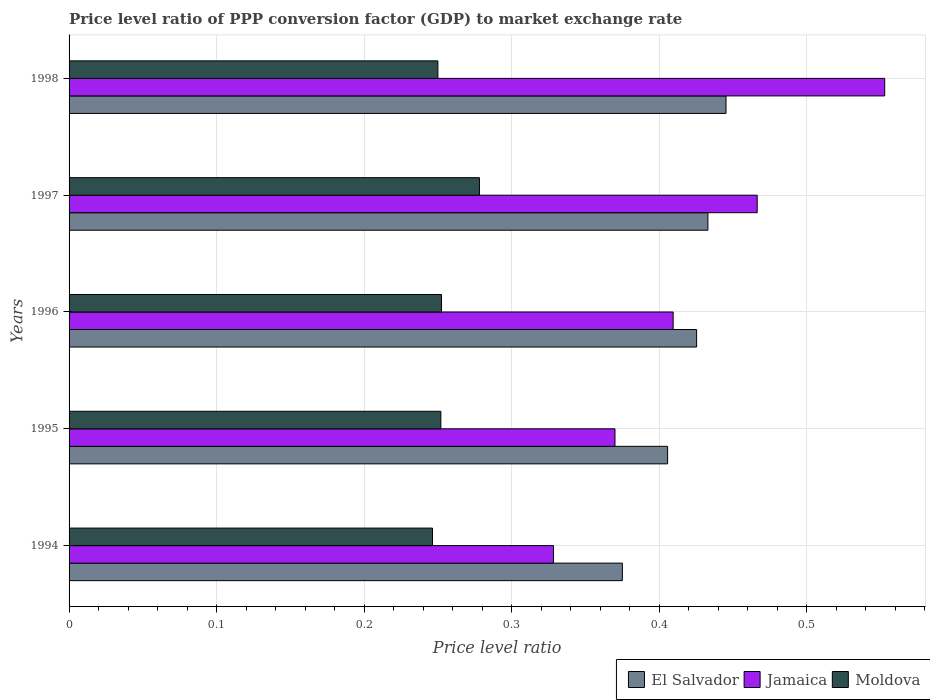How many different coloured bars are there?
Your response must be concise. 3. Are the number of bars per tick equal to the number of legend labels?
Offer a terse response. Yes. Are the number of bars on each tick of the Y-axis equal?
Keep it short and to the point. Yes. How many bars are there on the 3rd tick from the top?
Give a very brief answer. 3. How many bars are there on the 4th tick from the bottom?
Provide a succinct answer. 3. What is the price level ratio in Jamaica in 1994?
Your answer should be compact. 0.33. Across all years, what is the maximum price level ratio in El Salvador?
Make the answer very short. 0.45. Across all years, what is the minimum price level ratio in Jamaica?
Give a very brief answer. 0.33. In which year was the price level ratio in El Salvador maximum?
Give a very brief answer. 1998. What is the total price level ratio in El Salvador in the graph?
Provide a short and direct response. 2.08. What is the difference between the price level ratio in Moldova in 1994 and that in 1997?
Your answer should be very brief. -0.03. What is the difference between the price level ratio in Moldova in 1998 and the price level ratio in El Salvador in 1995?
Your answer should be very brief. -0.16. What is the average price level ratio in El Salvador per year?
Make the answer very short. 0.42. In the year 1995, what is the difference between the price level ratio in Moldova and price level ratio in Jamaica?
Offer a terse response. -0.12. In how many years, is the price level ratio in Jamaica greater than 0.06 ?
Ensure brevity in your answer.  5. What is the ratio of the price level ratio in El Salvador in 1994 to that in 1998?
Offer a very short reply. 0.84. Is the price level ratio in Moldova in 1994 less than that in 1998?
Provide a short and direct response. Yes. What is the difference between the highest and the second highest price level ratio in Moldova?
Your answer should be very brief. 0.03. What is the difference between the highest and the lowest price level ratio in Moldova?
Keep it short and to the point. 0.03. In how many years, is the price level ratio in El Salvador greater than the average price level ratio in El Salvador taken over all years?
Make the answer very short. 3. What does the 2nd bar from the top in 1995 represents?
Give a very brief answer. Jamaica. What does the 2nd bar from the bottom in 1998 represents?
Ensure brevity in your answer.  Jamaica. Is it the case that in every year, the sum of the price level ratio in El Salvador and price level ratio in Jamaica is greater than the price level ratio in Moldova?
Give a very brief answer. Yes. How many bars are there?
Provide a short and direct response. 15. Are the values on the major ticks of X-axis written in scientific E-notation?
Your answer should be very brief. No. What is the title of the graph?
Your answer should be compact. Price level ratio of PPP conversion factor (GDP) to market exchange rate. Does "Vanuatu" appear as one of the legend labels in the graph?
Give a very brief answer. No. What is the label or title of the X-axis?
Offer a very short reply. Price level ratio. What is the label or title of the Y-axis?
Your answer should be very brief. Years. What is the Price level ratio of El Salvador in 1994?
Keep it short and to the point. 0.37. What is the Price level ratio of Jamaica in 1994?
Give a very brief answer. 0.33. What is the Price level ratio in Moldova in 1994?
Your response must be concise. 0.25. What is the Price level ratio of El Salvador in 1995?
Offer a very short reply. 0.41. What is the Price level ratio in Jamaica in 1995?
Your response must be concise. 0.37. What is the Price level ratio in Moldova in 1995?
Keep it short and to the point. 0.25. What is the Price level ratio of El Salvador in 1996?
Provide a short and direct response. 0.43. What is the Price level ratio in Jamaica in 1996?
Your response must be concise. 0.41. What is the Price level ratio in Moldova in 1996?
Keep it short and to the point. 0.25. What is the Price level ratio of El Salvador in 1997?
Give a very brief answer. 0.43. What is the Price level ratio of Jamaica in 1997?
Provide a succinct answer. 0.47. What is the Price level ratio of Moldova in 1997?
Give a very brief answer. 0.28. What is the Price level ratio in El Salvador in 1998?
Offer a very short reply. 0.45. What is the Price level ratio of Jamaica in 1998?
Offer a terse response. 0.55. What is the Price level ratio in Moldova in 1998?
Offer a very short reply. 0.25. Across all years, what is the maximum Price level ratio in El Salvador?
Offer a very short reply. 0.45. Across all years, what is the maximum Price level ratio of Jamaica?
Your answer should be compact. 0.55. Across all years, what is the maximum Price level ratio of Moldova?
Provide a short and direct response. 0.28. Across all years, what is the minimum Price level ratio of El Salvador?
Your answer should be compact. 0.37. Across all years, what is the minimum Price level ratio of Jamaica?
Your answer should be very brief. 0.33. Across all years, what is the minimum Price level ratio of Moldova?
Provide a short and direct response. 0.25. What is the total Price level ratio of El Salvador in the graph?
Your response must be concise. 2.08. What is the total Price level ratio in Jamaica in the graph?
Your answer should be compact. 2.13. What is the total Price level ratio of Moldova in the graph?
Give a very brief answer. 1.28. What is the difference between the Price level ratio in El Salvador in 1994 and that in 1995?
Provide a succinct answer. -0.03. What is the difference between the Price level ratio in Jamaica in 1994 and that in 1995?
Your answer should be compact. -0.04. What is the difference between the Price level ratio of Moldova in 1994 and that in 1995?
Keep it short and to the point. -0.01. What is the difference between the Price level ratio in El Salvador in 1994 and that in 1996?
Your response must be concise. -0.05. What is the difference between the Price level ratio of Jamaica in 1994 and that in 1996?
Offer a very short reply. -0.08. What is the difference between the Price level ratio of Moldova in 1994 and that in 1996?
Ensure brevity in your answer.  -0.01. What is the difference between the Price level ratio of El Salvador in 1994 and that in 1997?
Your answer should be very brief. -0.06. What is the difference between the Price level ratio in Jamaica in 1994 and that in 1997?
Provide a succinct answer. -0.14. What is the difference between the Price level ratio of Moldova in 1994 and that in 1997?
Offer a terse response. -0.03. What is the difference between the Price level ratio of El Salvador in 1994 and that in 1998?
Give a very brief answer. -0.07. What is the difference between the Price level ratio of Jamaica in 1994 and that in 1998?
Your response must be concise. -0.22. What is the difference between the Price level ratio of Moldova in 1994 and that in 1998?
Ensure brevity in your answer.  -0. What is the difference between the Price level ratio in El Salvador in 1995 and that in 1996?
Your answer should be compact. -0.02. What is the difference between the Price level ratio of Jamaica in 1995 and that in 1996?
Provide a short and direct response. -0.04. What is the difference between the Price level ratio of Moldova in 1995 and that in 1996?
Provide a short and direct response. -0. What is the difference between the Price level ratio of El Salvador in 1995 and that in 1997?
Give a very brief answer. -0.03. What is the difference between the Price level ratio in Jamaica in 1995 and that in 1997?
Keep it short and to the point. -0.1. What is the difference between the Price level ratio of Moldova in 1995 and that in 1997?
Provide a short and direct response. -0.03. What is the difference between the Price level ratio of El Salvador in 1995 and that in 1998?
Keep it short and to the point. -0.04. What is the difference between the Price level ratio in Jamaica in 1995 and that in 1998?
Ensure brevity in your answer.  -0.18. What is the difference between the Price level ratio in Moldova in 1995 and that in 1998?
Provide a succinct answer. 0. What is the difference between the Price level ratio in El Salvador in 1996 and that in 1997?
Provide a short and direct response. -0.01. What is the difference between the Price level ratio of Jamaica in 1996 and that in 1997?
Your answer should be compact. -0.06. What is the difference between the Price level ratio in Moldova in 1996 and that in 1997?
Offer a terse response. -0.03. What is the difference between the Price level ratio of El Salvador in 1996 and that in 1998?
Offer a very short reply. -0.02. What is the difference between the Price level ratio of Jamaica in 1996 and that in 1998?
Provide a short and direct response. -0.14. What is the difference between the Price level ratio of Moldova in 1996 and that in 1998?
Your answer should be very brief. 0. What is the difference between the Price level ratio of El Salvador in 1997 and that in 1998?
Offer a very short reply. -0.01. What is the difference between the Price level ratio of Jamaica in 1997 and that in 1998?
Provide a succinct answer. -0.09. What is the difference between the Price level ratio in Moldova in 1997 and that in 1998?
Offer a very short reply. 0.03. What is the difference between the Price level ratio of El Salvador in 1994 and the Price level ratio of Jamaica in 1995?
Give a very brief answer. 0.01. What is the difference between the Price level ratio of El Salvador in 1994 and the Price level ratio of Moldova in 1995?
Your answer should be very brief. 0.12. What is the difference between the Price level ratio of Jamaica in 1994 and the Price level ratio of Moldova in 1995?
Offer a terse response. 0.08. What is the difference between the Price level ratio of El Salvador in 1994 and the Price level ratio of Jamaica in 1996?
Your response must be concise. -0.03. What is the difference between the Price level ratio of El Salvador in 1994 and the Price level ratio of Moldova in 1996?
Your answer should be very brief. 0.12. What is the difference between the Price level ratio in Jamaica in 1994 and the Price level ratio in Moldova in 1996?
Offer a terse response. 0.08. What is the difference between the Price level ratio of El Salvador in 1994 and the Price level ratio of Jamaica in 1997?
Provide a succinct answer. -0.09. What is the difference between the Price level ratio in El Salvador in 1994 and the Price level ratio in Moldova in 1997?
Ensure brevity in your answer.  0.1. What is the difference between the Price level ratio of Jamaica in 1994 and the Price level ratio of Moldova in 1997?
Make the answer very short. 0.05. What is the difference between the Price level ratio in El Salvador in 1994 and the Price level ratio in Jamaica in 1998?
Provide a succinct answer. -0.18. What is the difference between the Price level ratio in El Salvador in 1994 and the Price level ratio in Moldova in 1998?
Provide a short and direct response. 0.12. What is the difference between the Price level ratio in Jamaica in 1994 and the Price level ratio in Moldova in 1998?
Ensure brevity in your answer.  0.08. What is the difference between the Price level ratio in El Salvador in 1995 and the Price level ratio in Jamaica in 1996?
Ensure brevity in your answer.  -0. What is the difference between the Price level ratio of El Salvador in 1995 and the Price level ratio of Moldova in 1996?
Provide a short and direct response. 0.15. What is the difference between the Price level ratio of Jamaica in 1995 and the Price level ratio of Moldova in 1996?
Ensure brevity in your answer.  0.12. What is the difference between the Price level ratio in El Salvador in 1995 and the Price level ratio in Jamaica in 1997?
Provide a succinct answer. -0.06. What is the difference between the Price level ratio of El Salvador in 1995 and the Price level ratio of Moldova in 1997?
Your answer should be very brief. 0.13. What is the difference between the Price level ratio in Jamaica in 1995 and the Price level ratio in Moldova in 1997?
Keep it short and to the point. 0.09. What is the difference between the Price level ratio of El Salvador in 1995 and the Price level ratio of Jamaica in 1998?
Your answer should be compact. -0.15. What is the difference between the Price level ratio of El Salvador in 1995 and the Price level ratio of Moldova in 1998?
Ensure brevity in your answer.  0.16. What is the difference between the Price level ratio of Jamaica in 1995 and the Price level ratio of Moldova in 1998?
Offer a terse response. 0.12. What is the difference between the Price level ratio in El Salvador in 1996 and the Price level ratio in Jamaica in 1997?
Offer a terse response. -0.04. What is the difference between the Price level ratio of El Salvador in 1996 and the Price level ratio of Moldova in 1997?
Provide a short and direct response. 0.15. What is the difference between the Price level ratio of Jamaica in 1996 and the Price level ratio of Moldova in 1997?
Your response must be concise. 0.13. What is the difference between the Price level ratio of El Salvador in 1996 and the Price level ratio of Jamaica in 1998?
Keep it short and to the point. -0.13. What is the difference between the Price level ratio in El Salvador in 1996 and the Price level ratio in Moldova in 1998?
Offer a very short reply. 0.18. What is the difference between the Price level ratio of Jamaica in 1996 and the Price level ratio of Moldova in 1998?
Keep it short and to the point. 0.16. What is the difference between the Price level ratio in El Salvador in 1997 and the Price level ratio in Jamaica in 1998?
Your response must be concise. -0.12. What is the difference between the Price level ratio of El Salvador in 1997 and the Price level ratio of Moldova in 1998?
Make the answer very short. 0.18. What is the difference between the Price level ratio in Jamaica in 1997 and the Price level ratio in Moldova in 1998?
Your response must be concise. 0.22. What is the average Price level ratio of El Salvador per year?
Provide a short and direct response. 0.42. What is the average Price level ratio in Jamaica per year?
Provide a succinct answer. 0.43. What is the average Price level ratio of Moldova per year?
Ensure brevity in your answer.  0.26. In the year 1994, what is the difference between the Price level ratio of El Salvador and Price level ratio of Jamaica?
Offer a very short reply. 0.05. In the year 1994, what is the difference between the Price level ratio of El Salvador and Price level ratio of Moldova?
Make the answer very short. 0.13. In the year 1994, what is the difference between the Price level ratio in Jamaica and Price level ratio in Moldova?
Make the answer very short. 0.08. In the year 1995, what is the difference between the Price level ratio in El Salvador and Price level ratio in Jamaica?
Provide a short and direct response. 0.04. In the year 1995, what is the difference between the Price level ratio of El Salvador and Price level ratio of Moldova?
Your response must be concise. 0.15. In the year 1995, what is the difference between the Price level ratio of Jamaica and Price level ratio of Moldova?
Provide a short and direct response. 0.12. In the year 1996, what is the difference between the Price level ratio of El Salvador and Price level ratio of Jamaica?
Provide a succinct answer. 0.02. In the year 1996, what is the difference between the Price level ratio in El Salvador and Price level ratio in Moldova?
Provide a short and direct response. 0.17. In the year 1996, what is the difference between the Price level ratio of Jamaica and Price level ratio of Moldova?
Make the answer very short. 0.16. In the year 1997, what is the difference between the Price level ratio of El Salvador and Price level ratio of Jamaica?
Offer a terse response. -0.03. In the year 1997, what is the difference between the Price level ratio of El Salvador and Price level ratio of Moldova?
Your answer should be very brief. 0.15. In the year 1997, what is the difference between the Price level ratio in Jamaica and Price level ratio in Moldova?
Your response must be concise. 0.19. In the year 1998, what is the difference between the Price level ratio in El Salvador and Price level ratio in Jamaica?
Give a very brief answer. -0.11. In the year 1998, what is the difference between the Price level ratio of El Salvador and Price level ratio of Moldova?
Your response must be concise. 0.2. In the year 1998, what is the difference between the Price level ratio of Jamaica and Price level ratio of Moldova?
Make the answer very short. 0.3. What is the ratio of the Price level ratio of El Salvador in 1994 to that in 1995?
Keep it short and to the point. 0.92. What is the ratio of the Price level ratio of Jamaica in 1994 to that in 1995?
Your answer should be very brief. 0.89. What is the ratio of the Price level ratio in Moldova in 1994 to that in 1995?
Make the answer very short. 0.98. What is the ratio of the Price level ratio of El Salvador in 1994 to that in 1996?
Offer a terse response. 0.88. What is the ratio of the Price level ratio in Jamaica in 1994 to that in 1996?
Your answer should be compact. 0.8. What is the ratio of the Price level ratio of Moldova in 1994 to that in 1996?
Give a very brief answer. 0.98. What is the ratio of the Price level ratio in El Salvador in 1994 to that in 1997?
Offer a terse response. 0.87. What is the ratio of the Price level ratio of Jamaica in 1994 to that in 1997?
Keep it short and to the point. 0.7. What is the ratio of the Price level ratio in Moldova in 1994 to that in 1997?
Provide a succinct answer. 0.89. What is the ratio of the Price level ratio in El Salvador in 1994 to that in 1998?
Ensure brevity in your answer.  0.84. What is the ratio of the Price level ratio in Jamaica in 1994 to that in 1998?
Your response must be concise. 0.59. What is the ratio of the Price level ratio in Moldova in 1994 to that in 1998?
Offer a very short reply. 0.99. What is the ratio of the Price level ratio in El Salvador in 1995 to that in 1996?
Ensure brevity in your answer.  0.95. What is the ratio of the Price level ratio in Jamaica in 1995 to that in 1996?
Ensure brevity in your answer.  0.9. What is the ratio of the Price level ratio in Moldova in 1995 to that in 1996?
Keep it short and to the point. 1. What is the ratio of the Price level ratio in El Salvador in 1995 to that in 1997?
Provide a short and direct response. 0.94. What is the ratio of the Price level ratio of Jamaica in 1995 to that in 1997?
Your answer should be very brief. 0.79. What is the ratio of the Price level ratio in Moldova in 1995 to that in 1997?
Offer a very short reply. 0.91. What is the ratio of the Price level ratio in El Salvador in 1995 to that in 1998?
Make the answer very short. 0.91. What is the ratio of the Price level ratio of Jamaica in 1995 to that in 1998?
Keep it short and to the point. 0.67. What is the ratio of the Price level ratio of El Salvador in 1996 to that in 1997?
Your answer should be compact. 0.98. What is the ratio of the Price level ratio in Jamaica in 1996 to that in 1997?
Offer a terse response. 0.88. What is the ratio of the Price level ratio of Moldova in 1996 to that in 1997?
Keep it short and to the point. 0.91. What is the ratio of the Price level ratio in El Salvador in 1996 to that in 1998?
Ensure brevity in your answer.  0.96. What is the ratio of the Price level ratio in Jamaica in 1996 to that in 1998?
Offer a very short reply. 0.74. What is the ratio of the Price level ratio in Moldova in 1996 to that in 1998?
Offer a very short reply. 1.01. What is the ratio of the Price level ratio of El Salvador in 1997 to that in 1998?
Your answer should be very brief. 0.97. What is the ratio of the Price level ratio of Jamaica in 1997 to that in 1998?
Provide a short and direct response. 0.84. What is the ratio of the Price level ratio of Moldova in 1997 to that in 1998?
Offer a very short reply. 1.11. What is the difference between the highest and the second highest Price level ratio in El Salvador?
Provide a succinct answer. 0.01. What is the difference between the highest and the second highest Price level ratio in Jamaica?
Give a very brief answer. 0.09. What is the difference between the highest and the second highest Price level ratio of Moldova?
Your response must be concise. 0.03. What is the difference between the highest and the lowest Price level ratio of El Salvador?
Your answer should be very brief. 0.07. What is the difference between the highest and the lowest Price level ratio of Jamaica?
Provide a succinct answer. 0.22. What is the difference between the highest and the lowest Price level ratio of Moldova?
Your answer should be very brief. 0.03. 